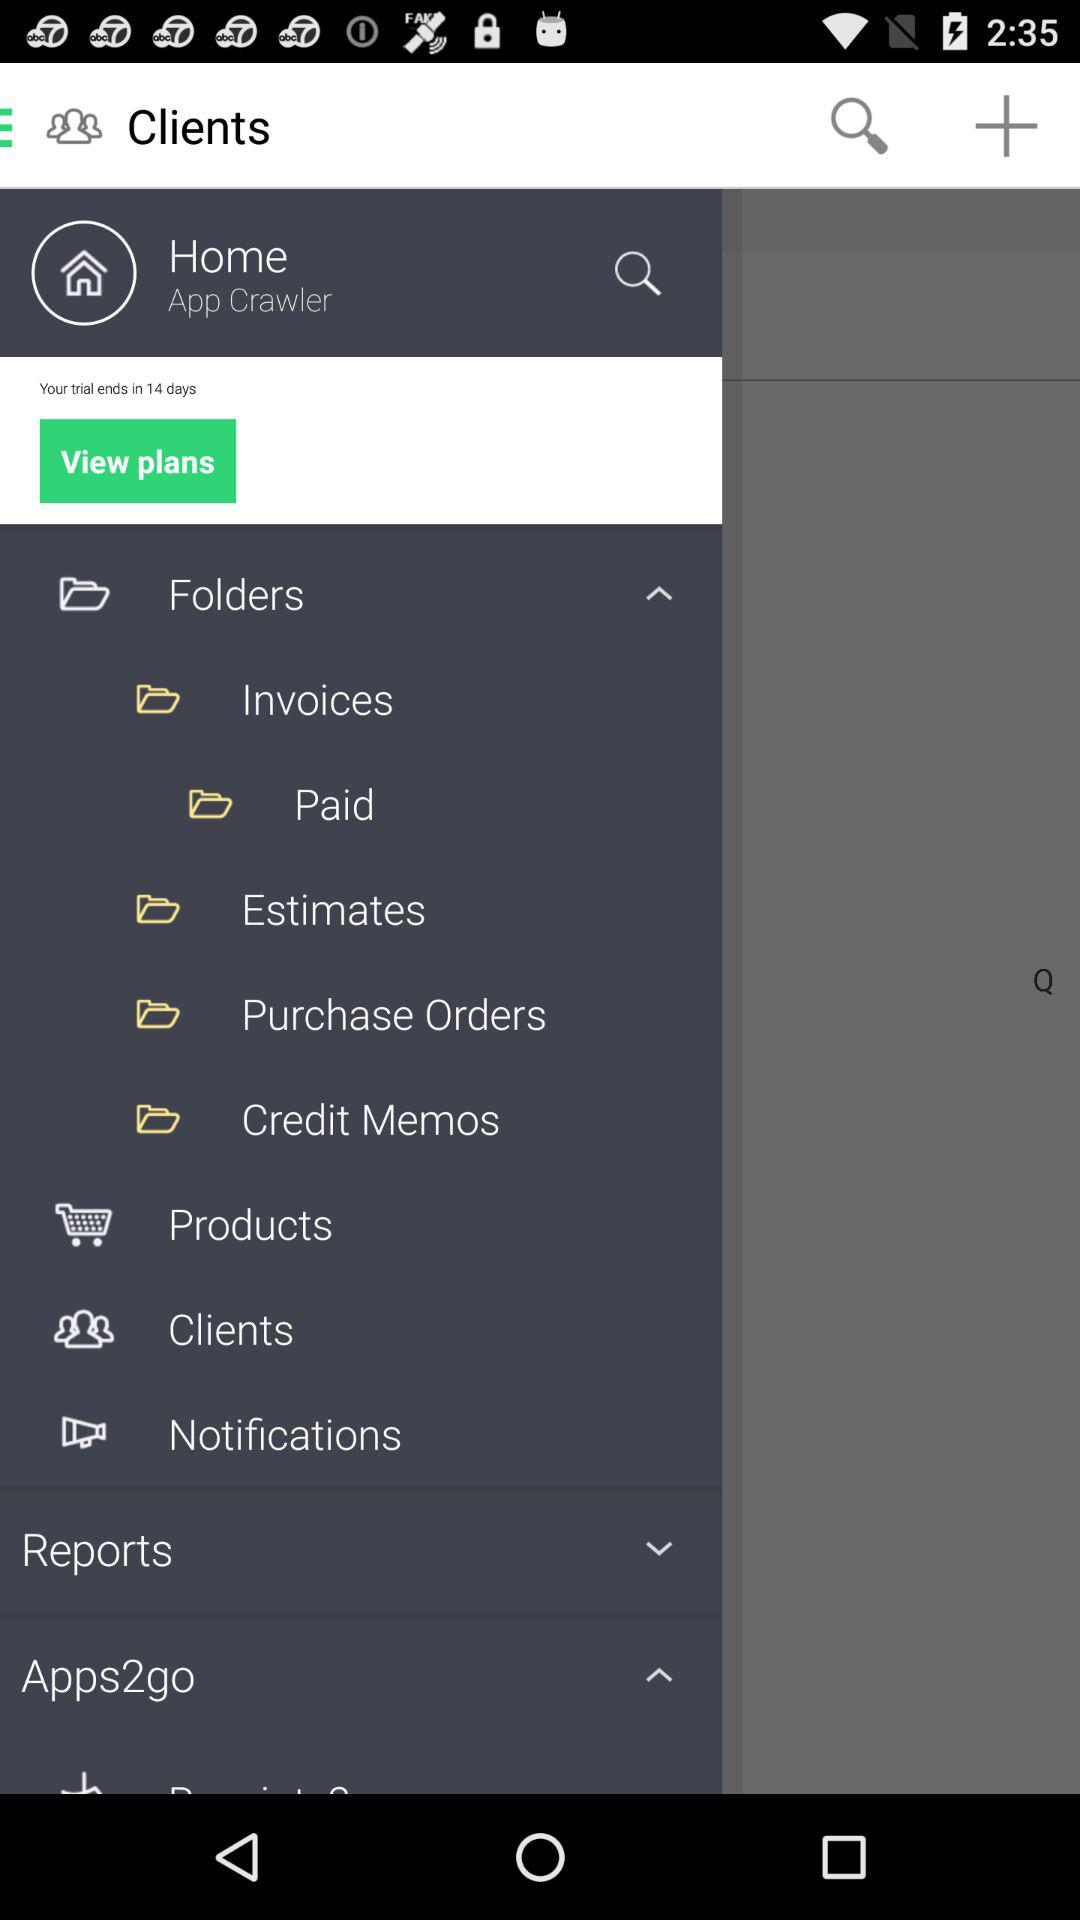What is the name of the application?
When the provided information is insufficient, respond with <no answer>. <no answer> 